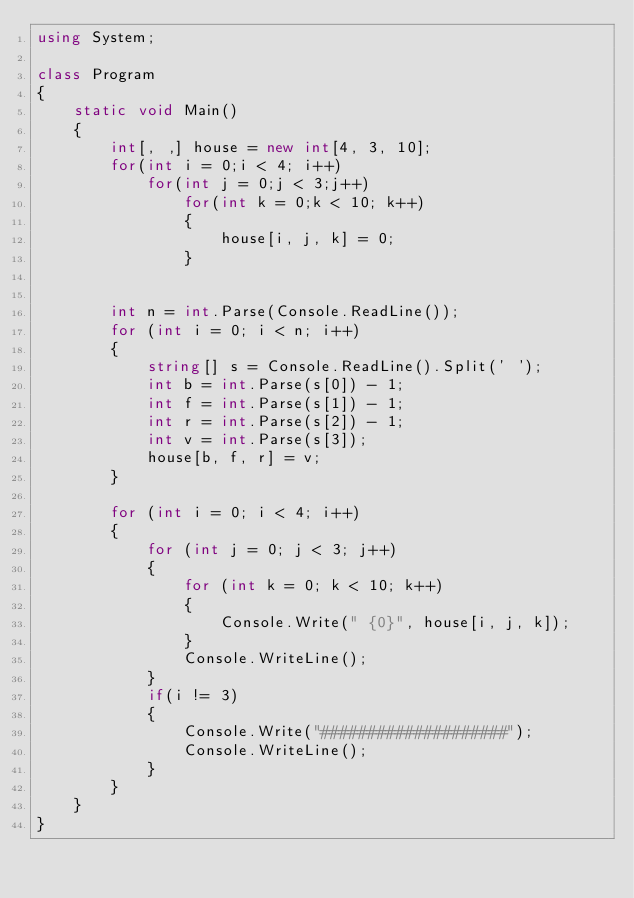Convert code to text. <code><loc_0><loc_0><loc_500><loc_500><_C#_>using System;

class Program
{
    static void Main()
    {
        int[, ,] house = new int[4, 3, 10];
        for(int i = 0;i < 4; i++)
            for(int j = 0;j < 3;j++)
                for(int k = 0;k < 10; k++)
                {
                    house[i, j, k] = 0;
                }


        int n = int.Parse(Console.ReadLine());
        for (int i = 0; i < n; i++)
        {
            string[] s = Console.ReadLine().Split(' ');
            int b = int.Parse(s[0]) - 1;
            int f = int.Parse(s[1]) - 1;
            int r = int.Parse(s[2]) - 1;
            int v = int.Parse(s[3]);
            house[b, f, r] = v;
        }

        for (int i = 0; i < 4; i++)
        {
            for (int j = 0; j < 3; j++)
            {
                for (int k = 0; k < 10; k++)
                {
                    Console.Write(" {0}", house[i, j, k]);
                }
                Console.WriteLine();
            }
            if(i != 3)
            {
                Console.Write("####################");
                Console.WriteLine();
            }
        }
    }
}</code> 